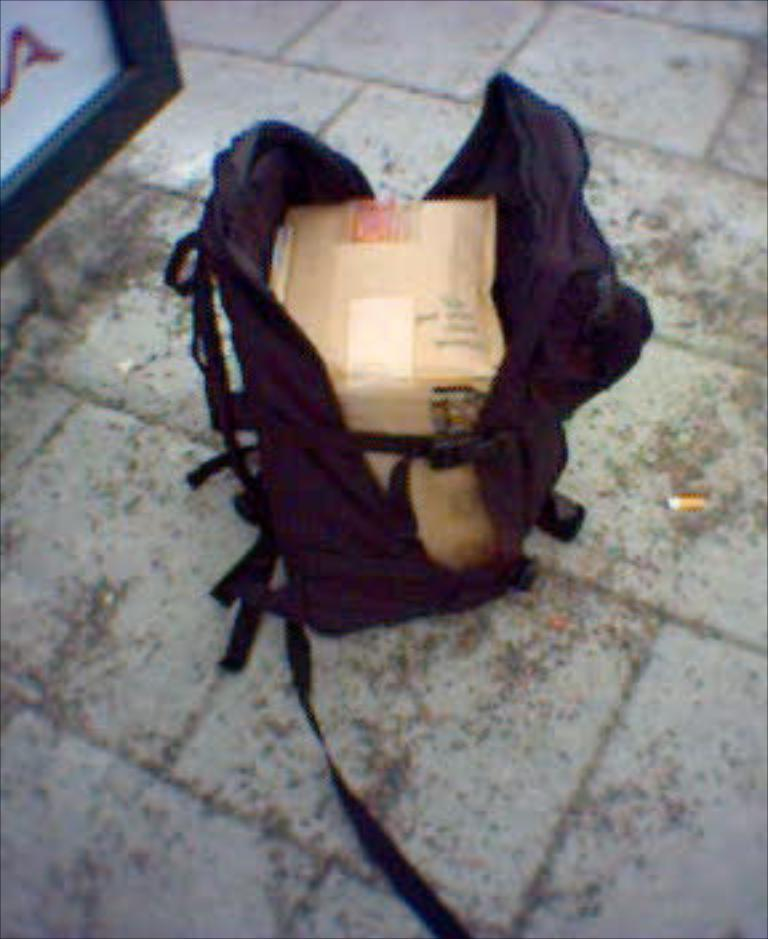What is on the floor in the image? There is a bag on the floor. What is inside the bag? There is a box inside the bag. What type of animal is biting the bag in the image? There is no animal present in the image, and therefore no biting can be observed. 